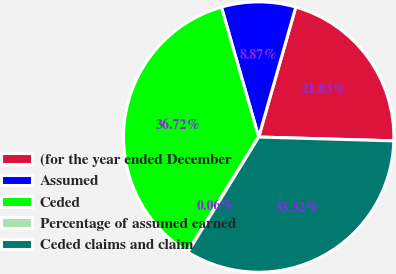Convert chart to OTSL. <chart><loc_0><loc_0><loc_500><loc_500><pie_chart><fcel>(for the year ended December<fcel>Assumed<fcel>Ceded<fcel>Percentage of assumed earned<fcel>Ceded claims and claim<nl><fcel>21.03%<fcel>8.87%<fcel>36.72%<fcel>0.06%<fcel>33.32%<nl></chart> 